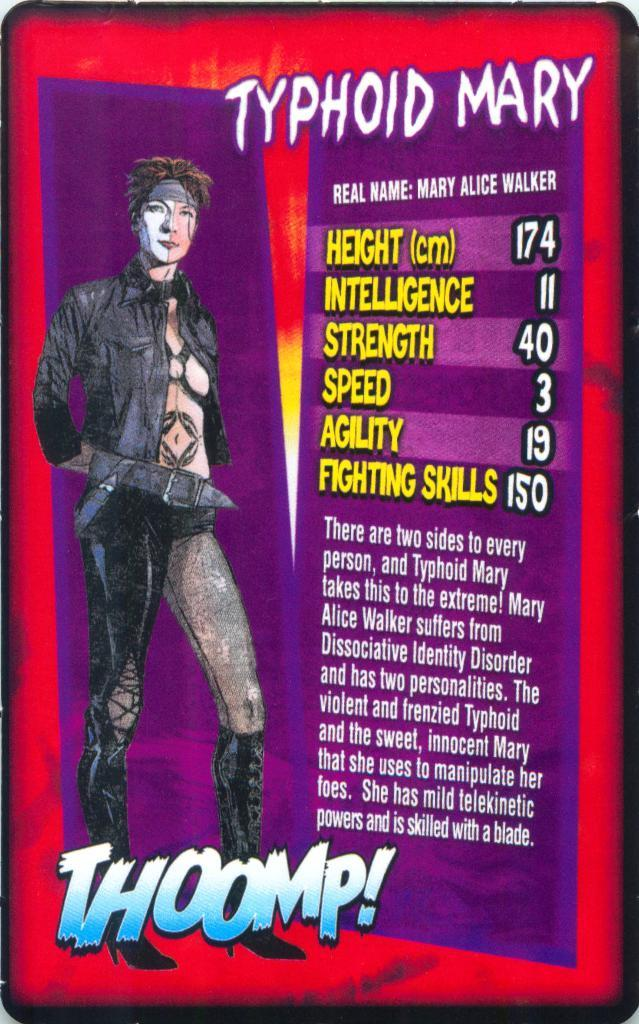What type of image is depicted in the poster? The image is a poster. What is the main subject of the poster? There is a picture of a person standing on the poster. What else is featured on the poster besides the image? There is text on the poster. Can you tell me how many friends are visible in the image? There is no reference to friends in the image; it features a picture of a person standing. What type of washing machine is shown in the image? There is no washing machine present in the image. 